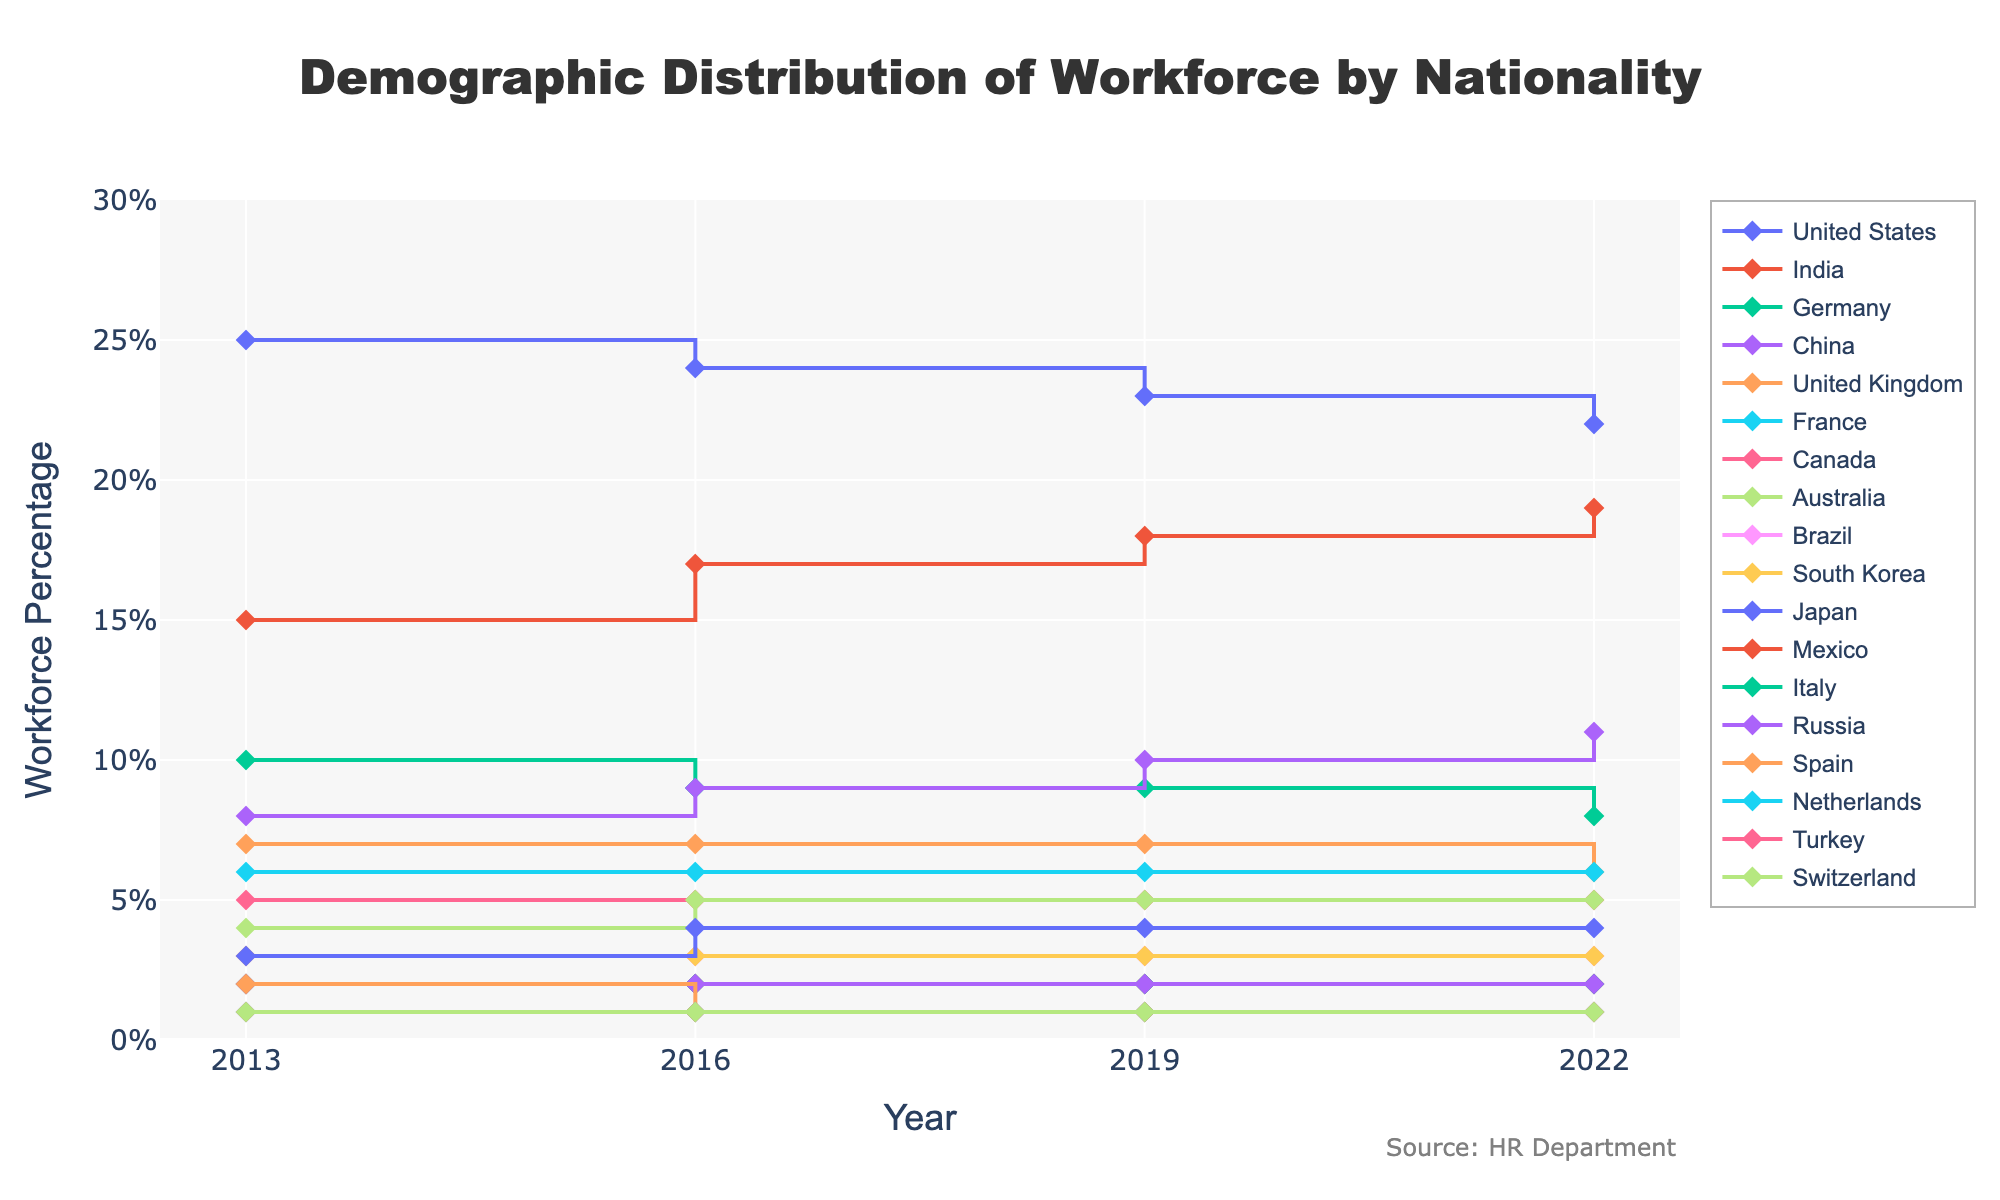What is the title of the figure? The title is located at the top center of the figure. It indicates the main subject or purpose of the plot.
Answer: Demographic Distribution of Workforce by Nationality What is the percentage of the workforce from India in 2019? Locate the year 2019 on the x-axis, find the line for India, and read the corresponding percentage from the y-axis.
Answer: 18% Which nationality had the highest workforce percentage in 2022? Look at the data points for the year 2022 on the x-axis, and identify which nationality line is the highest on the y-axis.
Answer: United States How did the workforce percentage for China change from 2013 to 2022? Find the data points for China in the years 2013 and 2022, and calculate the difference between 2022 and 2013 values. In 2013, it was 8%, and in 2022, it was 11%, so it increased by 3%.
Answer: Increased by 3% Which nationalities had a decreasing trend over the entire period? Examine the lines representing each nationality, and identify those where the final data point in 2022 is lower than the initial data point in 2013. Observe any lines continuously going down. United States (25% to 22%) and Germany (10% to 8%) both show decreasing trends.
Answer: United States, Germany How many nationalities were represented in the workforce in 2013? Count the number of unique nationalities listed for the year 2013 in the figure. There are multiple distinct lines starting from 2013.
Answer: 18 What is the combined percentage of the workforce for Japan and South Korea in 2016? Find the percentage points for Japan and South Korea in 2016, sum the values. Japan is 4% and South Korea is 3%, the total is 4% + 3% = 7%.
Answer: 7% Which nationality showed the highest percentage increase from 2013 to 2022? For each nationality, subtract the 2013 value from the 2022 value, and identify the largest difference. India increased from 15% to 19%, the largest increase of 4%.
Answer: India In which year did Australia’s workforce percentage change for the first time? Observe the line indicating Australia's workforce percentage and note the first transition or step change. The change from 4% to 5% occurred between 2013 and 2016.
Answer: 2016 What is the trend of the workforce percentage of the United Kingdom from 2013 to 2022? Trace the line representing the United Kingdom across all years, and describe its general direction. It starts at 7%, remains at 7% till 2019, and drops to 6% by 2022.
Answer: Slightly decreasing Which nationality had no change in workforce percentage over the decade? Identify any line that is completely horizontal across all years, indicating no change. Turkey and Switzerland both maintained 1% throughout the period.
Answer: Turkey, Switzerland 